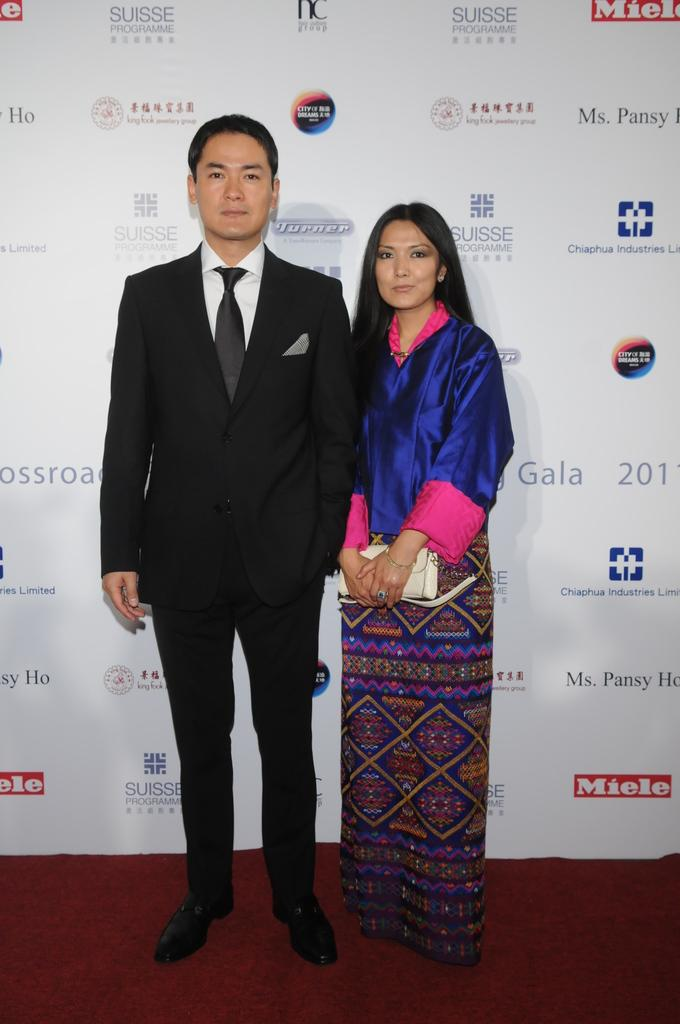How many people are present in the image? There are two people standing in the image. What color is the carpet in the image? The carpet in the image is red. What color is the background in the image? The background in the image is white. What is written or depicted on the white background? There is text on the white background. What type of mint can be seen growing on the pie in the image? There is no mint or pie present in the image; it features two people standing on a red carpet with a white background and text. 